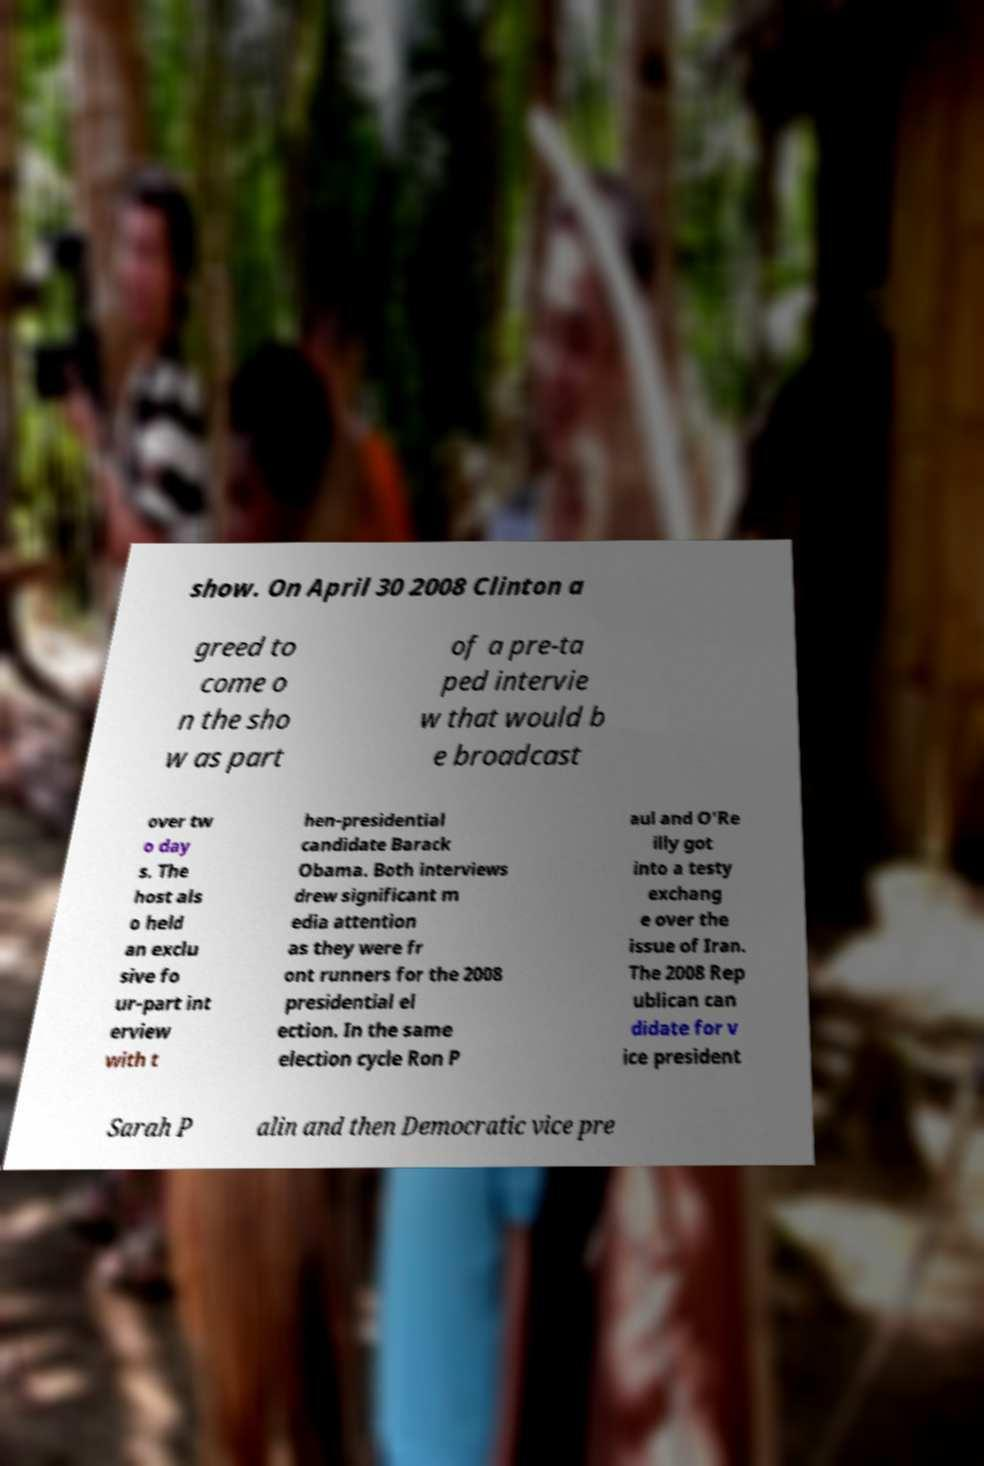Can you accurately transcribe the text from the provided image for me? show. On April 30 2008 Clinton a greed to come o n the sho w as part of a pre-ta ped intervie w that would b e broadcast over tw o day s. The host als o held an exclu sive fo ur-part int erview with t hen-presidential candidate Barack Obama. Both interviews drew significant m edia attention as they were fr ont runners for the 2008 presidential el ection. In the same election cycle Ron P aul and O'Re illy got into a testy exchang e over the issue of Iran. The 2008 Rep ublican can didate for v ice president Sarah P alin and then Democratic vice pre 